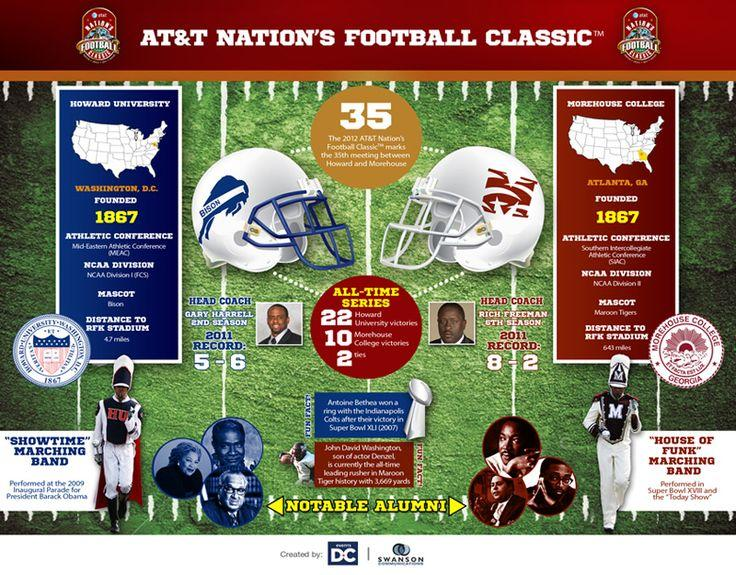Mention a couple of crucial points in this snapshot. Howard University has three notable alumni who have achieved significant recognition in their respective fields. The mascot of Howard University is a bison. The head coach of Morehouse College is Rich Freeman. The state that is a part of Morehouse College is Atlanta. Morehouse College was founded in 1867. 